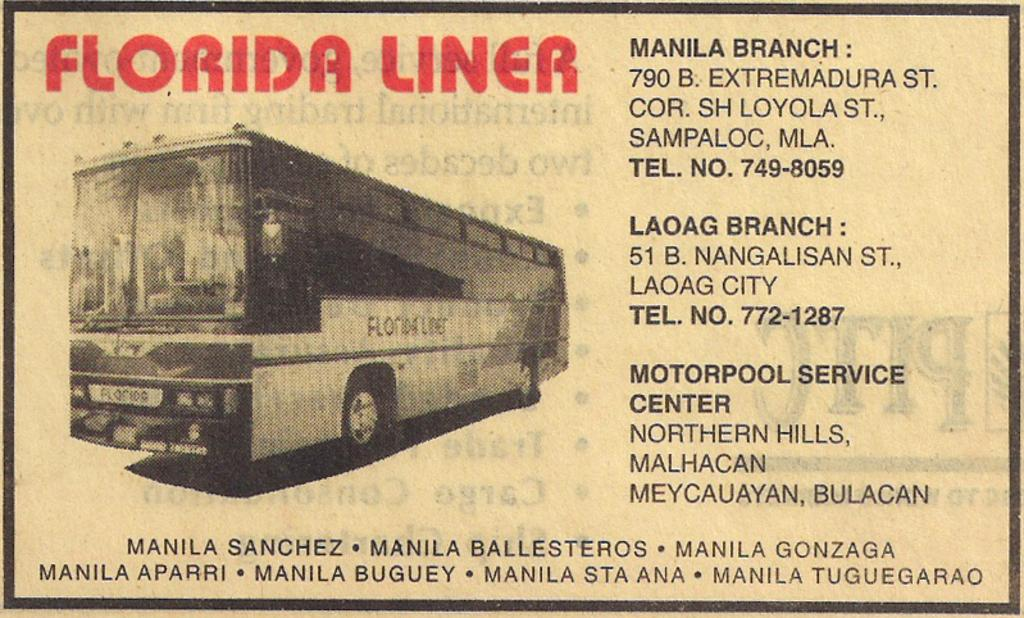What is featured in the picture? There is a poster in the picture. What can be seen on the left side of the poster? There is a bus depicted on the left side of the poster. What is present on the right side of the poster? There is text on the right side of the poster. How many wrists are visible on the poster? There are no wrists depicted on the poster; it features a bus and text. What is the fifth element on the poster? The poster only has three elements mentioned in the facts: a bus, text, and the poster itself. There is no fifth element. 